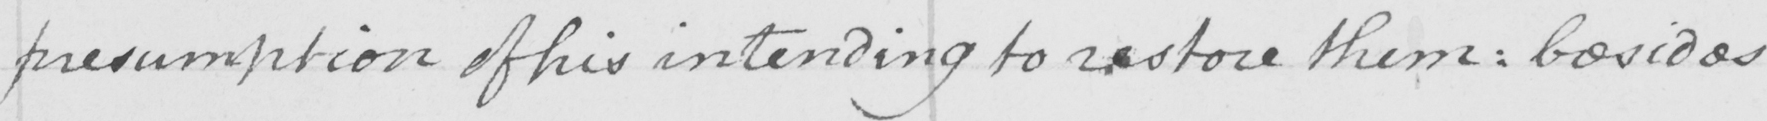Please transcribe the handwritten text in this image. presumption of his intending to restore them :  besides 